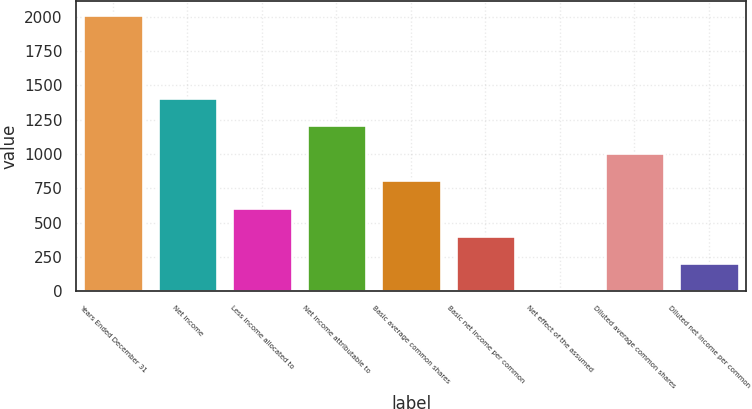Convert chart. <chart><loc_0><loc_0><loc_500><loc_500><bar_chart><fcel>Years Ended December 31<fcel>Net income<fcel>Less income allocated to<fcel>Net income attributable to<fcel>Basic average common shares<fcel>Basic net income per common<fcel>Net effect of the assumed<fcel>Diluted average common shares<fcel>Diluted net income per common<nl><fcel>2014<fcel>1410.4<fcel>605.6<fcel>1209.2<fcel>806.8<fcel>404.4<fcel>2<fcel>1008<fcel>203.2<nl></chart> 